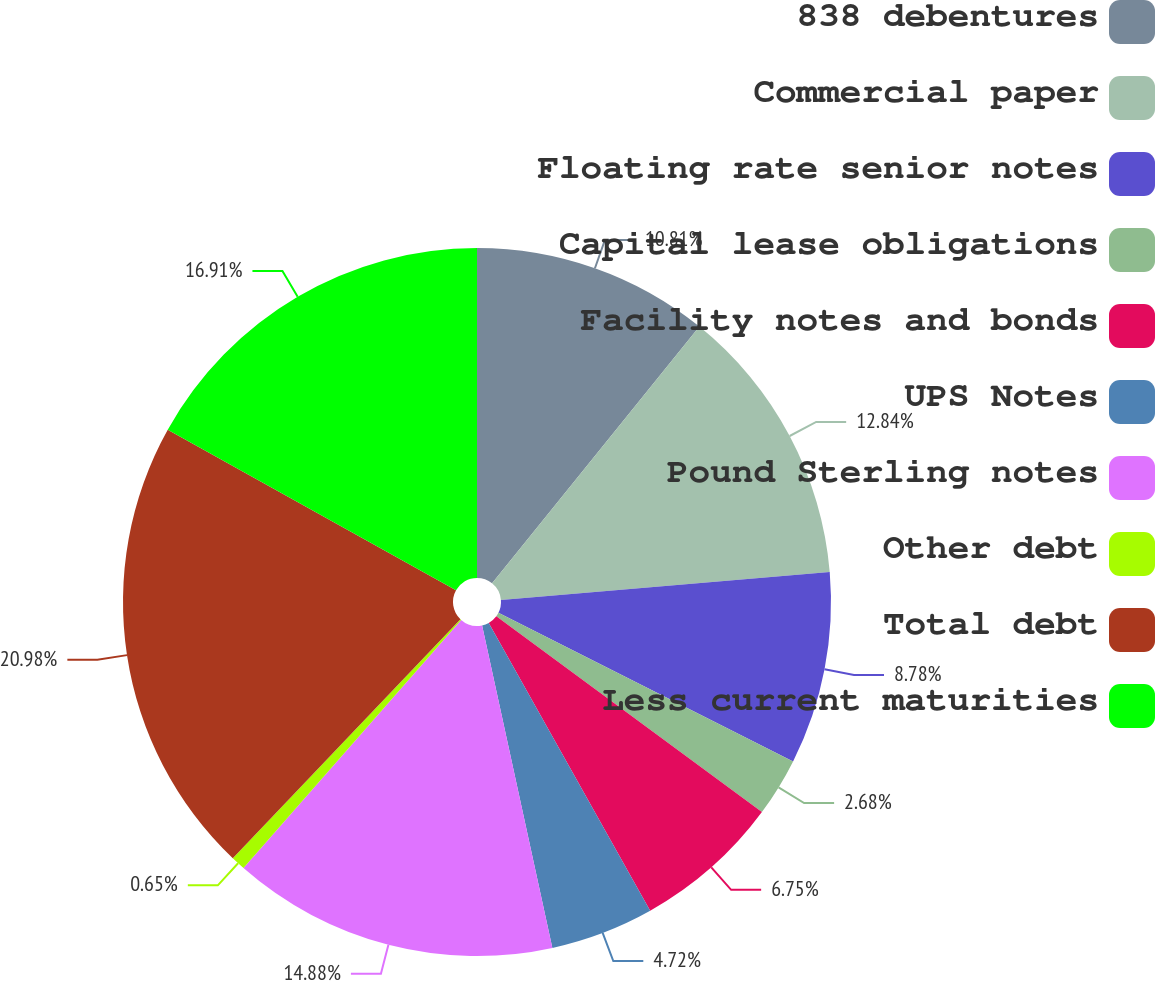<chart> <loc_0><loc_0><loc_500><loc_500><pie_chart><fcel>838 debentures<fcel>Commercial paper<fcel>Floating rate senior notes<fcel>Capital lease obligations<fcel>Facility notes and bonds<fcel>UPS Notes<fcel>Pound Sterling notes<fcel>Other debt<fcel>Total debt<fcel>Less current maturities<nl><fcel>10.81%<fcel>12.84%<fcel>8.78%<fcel>2.68%<fcel>6.75%<fcel>4.72%<fcel>14.88%<fcel>0.65%<fcel>20.97%<fcel>16.91%<nl></chart> 